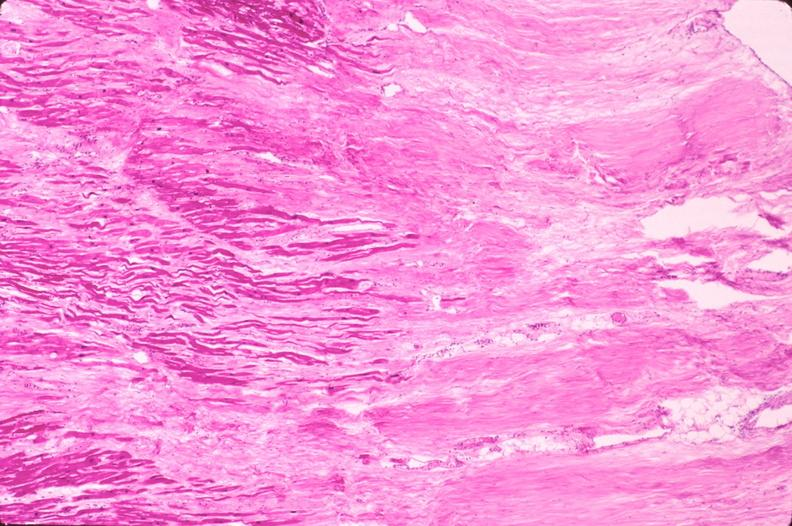what is present?
Answer the question using a single word or phrase. Cardiovascular 